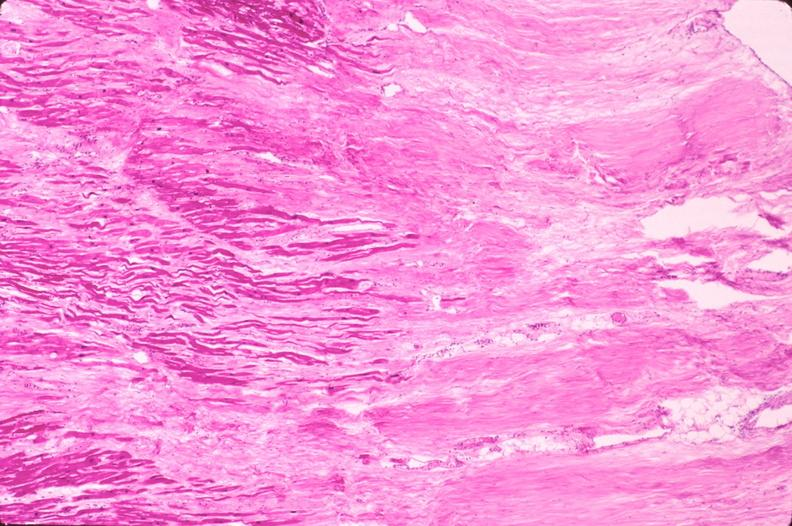what is present?
Answer the question using a single word or phrase. Cardiovascular 